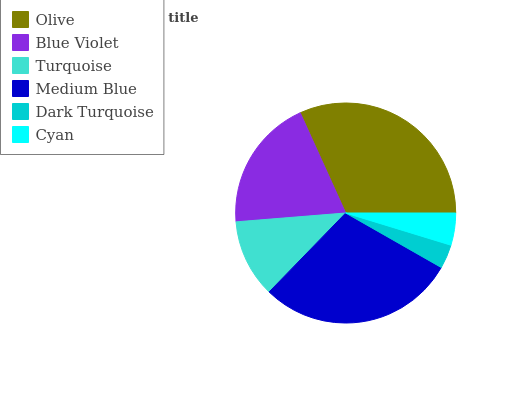Is Dark Turquoise the minimum?
Answer yes or no. Yes. Is Olive the maximum?
Answer yes or no. Yes. Is Blue Violet the minimum?
Answer yes or no. No. Is Blue Violet the maximum?
Answer yes or no. No. Is Olive greater than Blue Violet?
Answer yes or no. Yes. Is Blue Violet less than Olive?
Answer yes or no. Yes. Is Blue Violet greater than Olive?
Answer yes or no. No. Is Olive less than Blue Violet?
Answer yes or no. No. Is Blue Violet the high median?
Answer yes or no. Yes. Is Turquoise the low median?
Answer yes or no. Yes. Is Cyan the high median?
Answer yes or no. No. Is Dark Turquoise the low median?
Answer yes or no. No. 